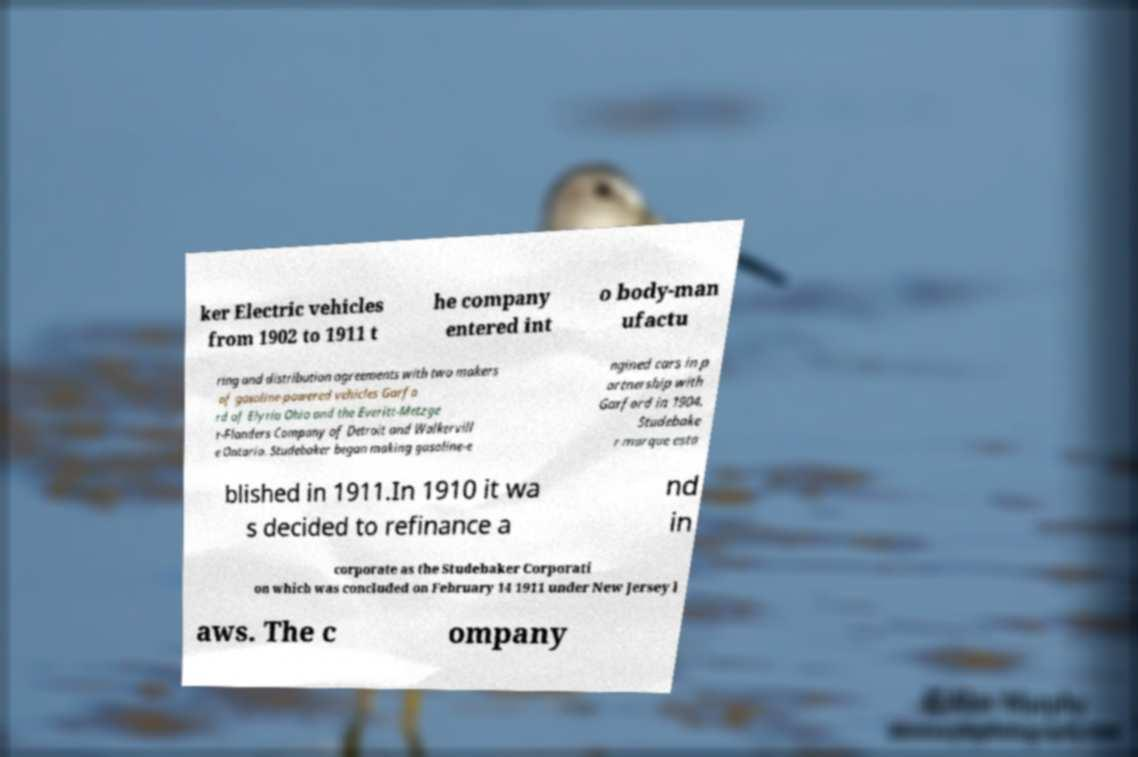I need the written content from this picture converted into text. Can you do that? ker Electric vehicles from 1902 to 1911 t he company entered int o body-man ufactu ring and distribution agreements with two makers of gasoline-powered vehicles Garfo rd of Elyria Ohio and the Everitt-Metzge r-Flanders Company of Detroit and Walkervill e Ontario. Studebaker began making gasoline-e ngined cars in p artnership with Garford in 1904. Studebake r marque esta blished in 1911.In 1910 it wa s decided to refinance a nd in corporate as the Studebaker Corporati on which was concluded on February 14 1911 under New Jersey l aws. The c ompany 